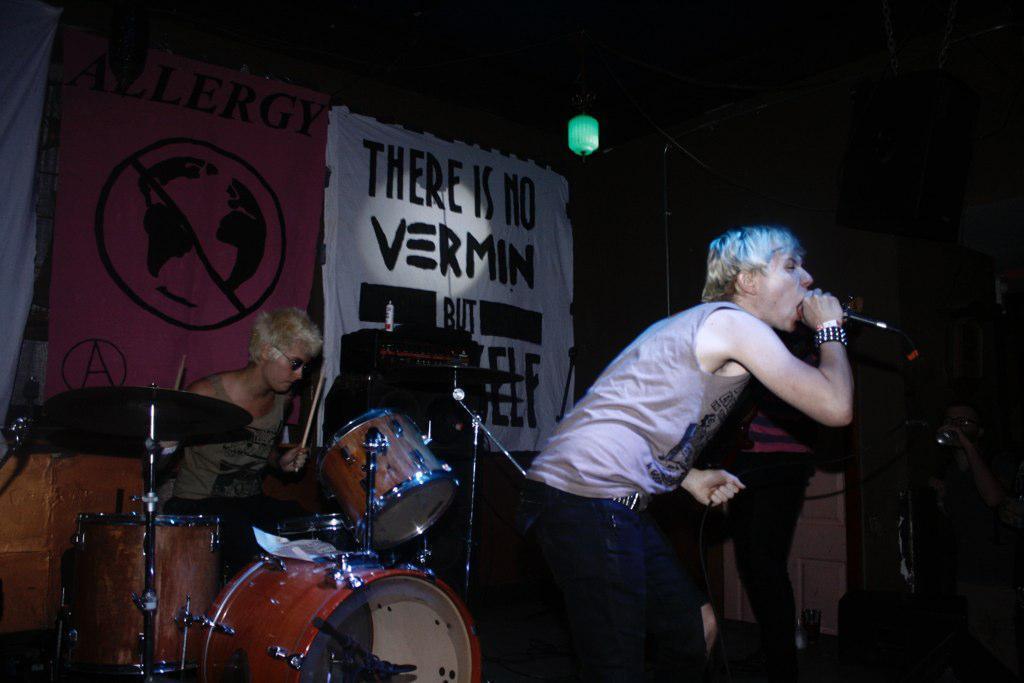Please provide a concise description of this image. There are two people in the picture one among them is holding the mike and the other is playing the band and there are two positions behind them which are in pink and white in color. 